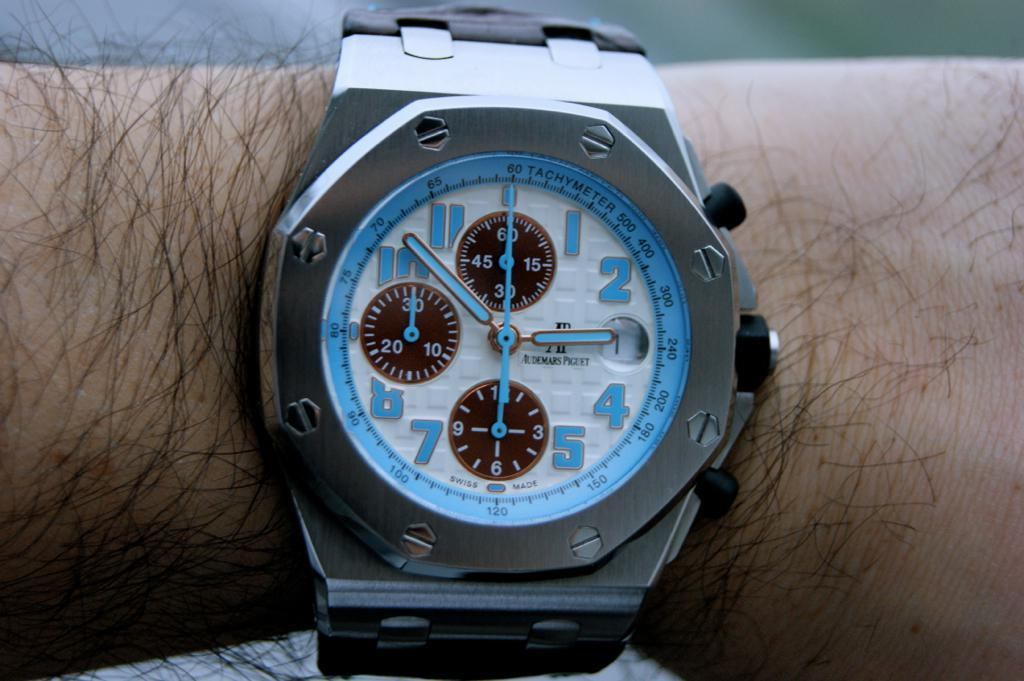What part of the human body is visible in the image? There is a human hand in the image. What is on the hand in the image? There is a watch on the hand. What type of curve can be seen in the image? There is no curve present in the image; it features a human hand with a watch on it. 